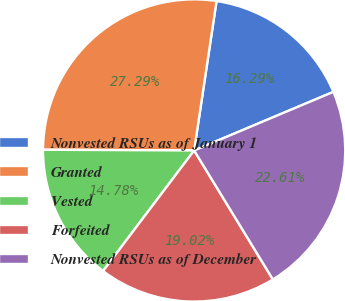<chart> <loc_0><loc_0><loc_500><loc_500><pie_chart><fcel>Nonvested RSUs as of January 1<fcel>Granted<fcel>Vested<fcel>Forfeited<fcel>Nonvested RSUs as of December<nl><fcel>16.29%<fcel>27.29%<fcel>14.78%<fcel>19.02%<fcel>22.61%<nl></chart> 